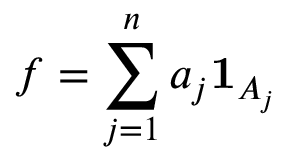<formula> <loc_0><loc_0><loc_500><loc_500>f = \sum _ { j = 1 } ^ { n } a _ { j } 1 _ { A _ { j } }</formula> 